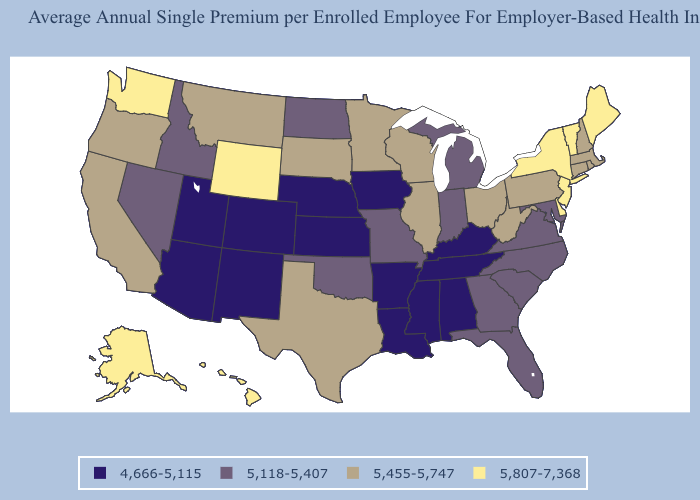What is the value of Mississippi?
Answer briefly. 4,666-5,115. What is the lowest value in the USA?
Write a very short answer. 4,666-5,115. Does Nebraska have the lowest value in the MidWest?
Give a very brief answer. Yes. Name the states that have a value in the range 5,118-5,407?
Keep it brief. Florida, Georgia, Idaho, Indiana, Maryland, Michigan, Missouri, Nevada, North Carolina, North Dakota, Oklahoma, South Carolina, Virginia. Which states have the highest value in the USA?
Concise answer only. Alaska, Delaware, Hawaii, Maine, New Jersey, New York, Vermont, Washington, Wyoming. What is the value of Washington?
Concise answer only. 5,807-7,368. Does the map have missing data?
Keep it brief. No. Does Alaska have the lowest value in the USA?
Short answer required. No. Name the states that have a value in the range 4,666-5,115?
Answer briefly. Alabama, Arizona, Arkansas, Colorado, Iowa, Kansas, Kentucky, Louisiana, Mississippi, Nebraska, New Mexico, Tennessee, Utah. What is the value of Alabama?
Be succinct. 4,666-5,115. Among the states that border New Jersey , which have the highest value?
Be succinct. Delaware, New York. Which states have the lowest value in the South?
Short answer required. Alabama, Arkansas, Kentucky, Louisiana, Mississippi, Tennessee. Does Utah have the lowest value in the USA?
Concise answer only. Yes. Does Massachusetts have the lowest value in the Northeast?
Write a very short answer. Yes. Does New Mexico have the lowest value in the USA?
Be succinct. Yes. 